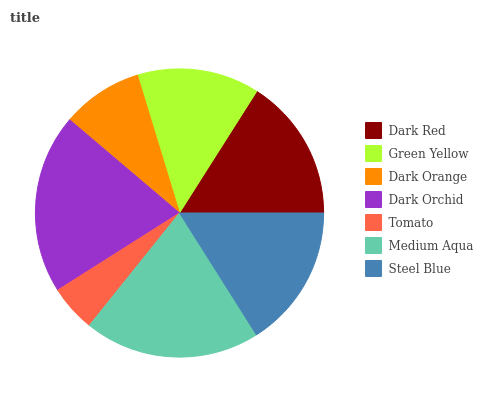Is Tomato the minimum?
Answer yes or no. Yes. Is Dark Orchid the maximum?
Answer yes or no. Yes. Is Green Yellow the minimum?
Answer yes or no. No. Is Green Yellow the maximum?
Answer yes or no. No. Is Dark Red greater than Green Yellow?
Answer yes or no. Yes. Is Green Yellow less than Dark Red?
Answer yes or no. Yes. Is Green Yellow greater than Dark Red?
Answer yes or no. No. Is Dark Red less than Green Yellow?
Answer yes or no. No. Is Dark Red the high median?
Answer yes or no. Yes. Is Dark Red the low median?
Answer yes or no. Yes. Is Medium Aqua the high median?
Answer yes or no. No. Is Dark Orchid the low median?
Answer yes or no. No. 